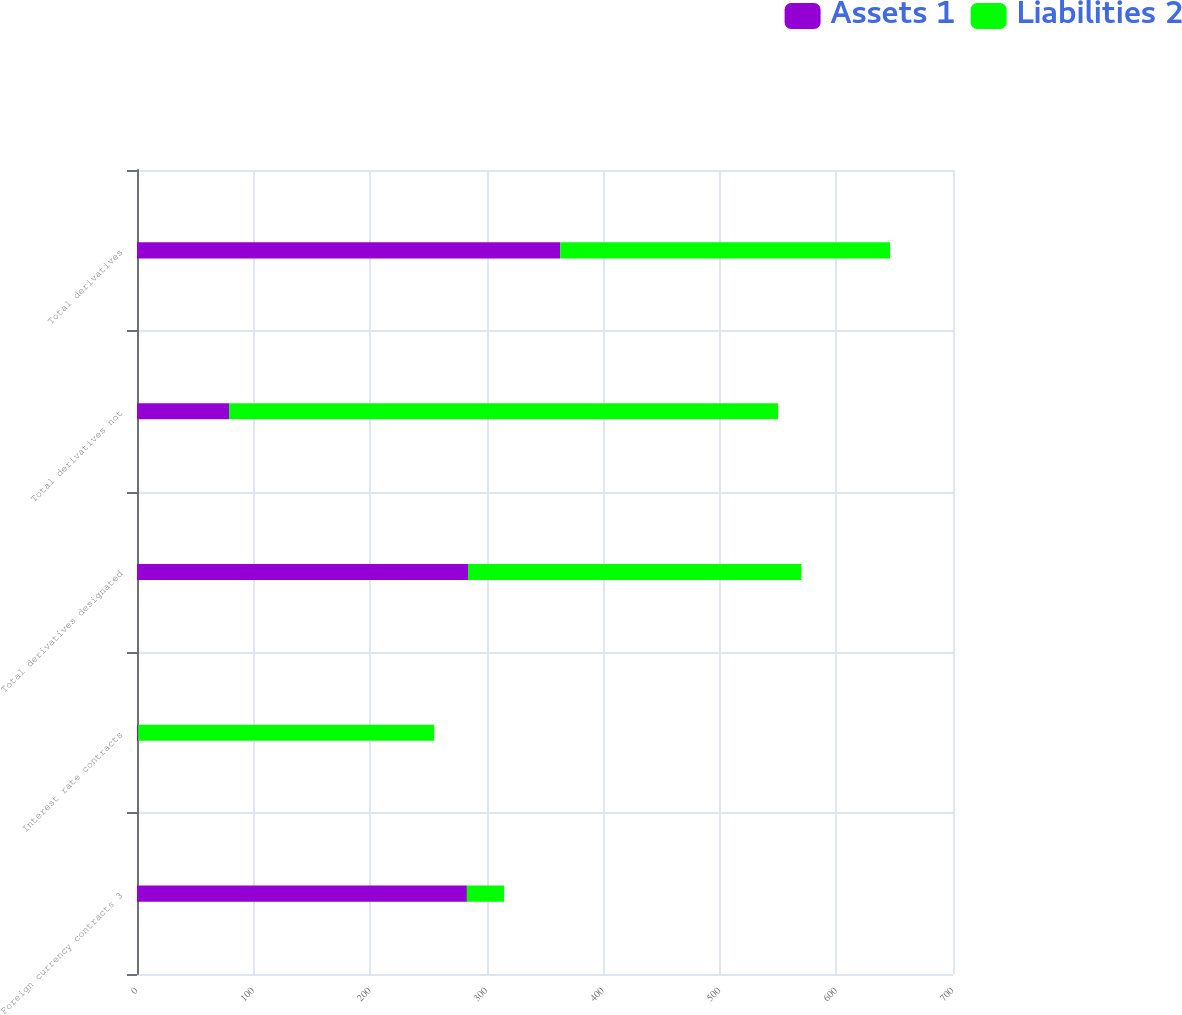Convert chart. <chart><loc_0><loc_0><loc_500><loc_500><stacked_bar_chart><ecel><fcel>Foreign currency contracts 3<fcel>Interest rate contracts<fcel>Total derivatives designated<fcel>Total derivatives not<fcel>Total derivatives<nl><fcel>Assets 1<fcel>283<fcel>1<fcel>284<fcel>79<fcel>363<nl><fcel>Liabilities 2<fcel>32<fcel>254<fcel>286<fcel>471<fcel>283<nl></chart> 